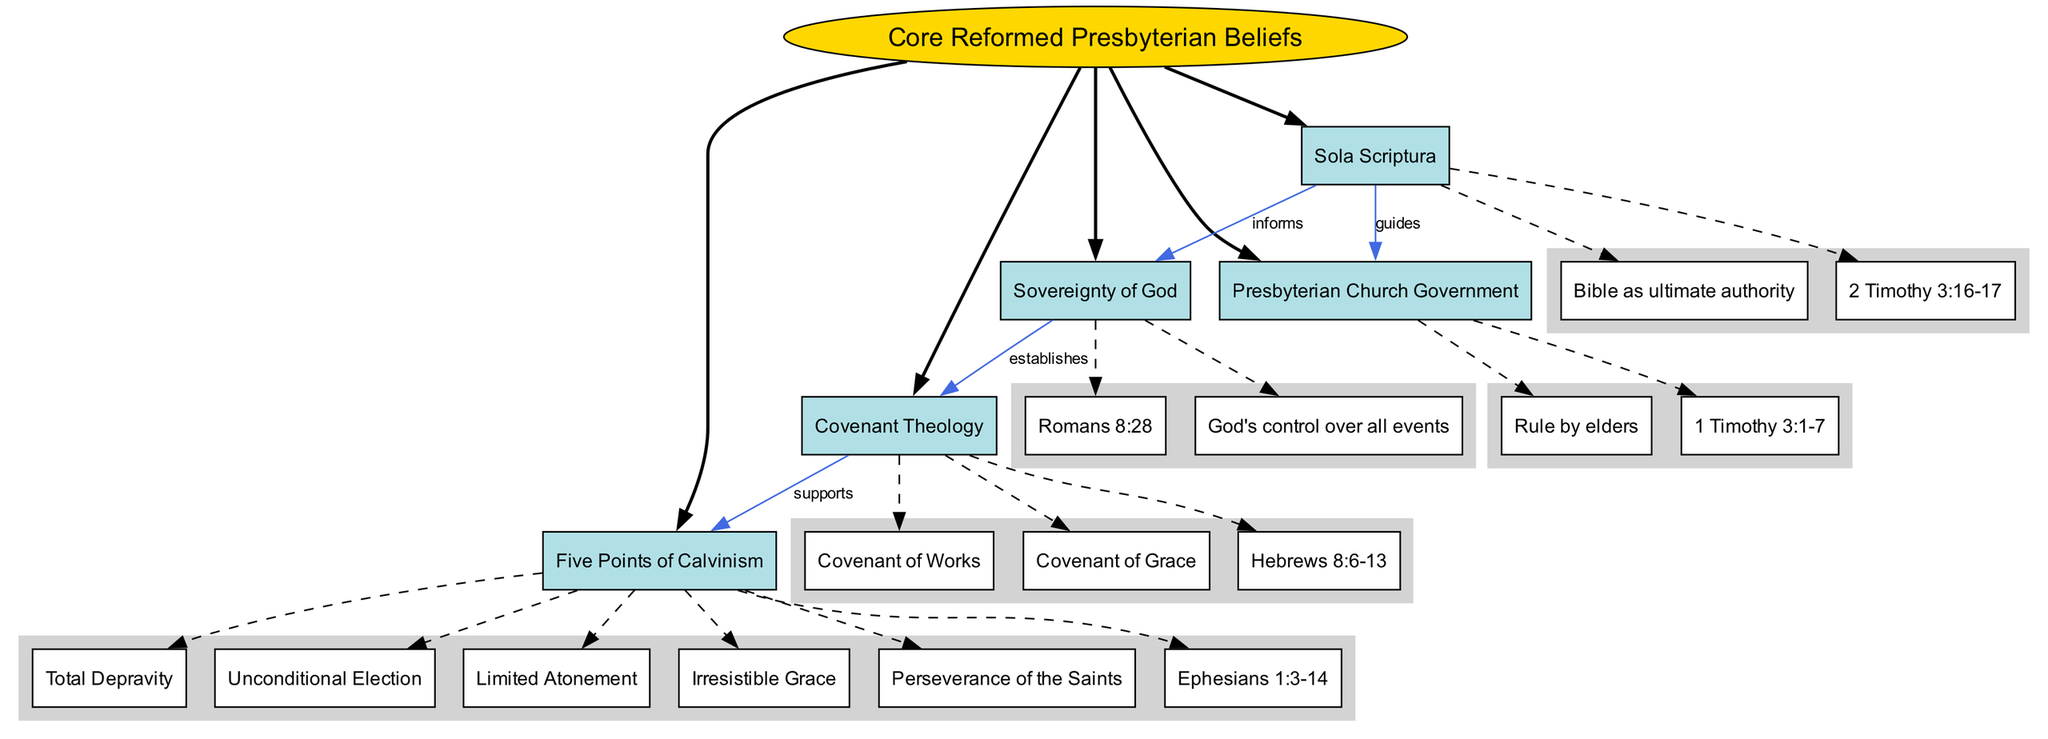What are the five core beliefs represented in the diagram? The diagram lists five main nodes that represent the core beliefs of Reformed Presbyterianism: Sola Scriptura, Sovereignty of God, Covenant Theology, Five Points of Calvinism, and Presbyterian Church Government.
Answer: Sola Scriptura, Sovereignty of God, Covenant Theology, Five Points of Calvinism, Presbyterian Church Government Which node details the Bible as the ultimate authority? The "Sola Scriptura" node is associated with the belief that the Bible is the ultimate authority. This is clearly shown in the sub-nodes connected to "Sola Scriptura".
Answer: Sola Scriptura How many sub-nodes are under Covenant Theology? The "Covenant Theology" node has three sub-nodes associated with it: Covenant of Works, Covenant of Grace, and the biblical reference of Hebrews 8:6-13, indicating there are three sub-nodes.
Answer: 3 What does the "Sovereignty of God" node inform? According to the diagram, "Sola Scriptura" informs "Sovereignty of God," as indicated by the connection labeled "informs."
Answer: Sola Scriptura Which biblical reference supports the Five Points of Calvinism? The "Five Points of Calvinism" node cites Ephesians 1:3-14 as its supporting biblical reference. This is directly stated in the sub-nodes for that main belief.
Answer: Ephesians 1:3-14 What establishes Covenant Theology according to the diagram? The diagram shows that "Sovereignty of God" establishes "Covenant Theology," as indicated by the connection labeled "establishes." This means that the belief in God's sovereignty lays the groundwork for understanding the covenants.
Answer: Sovereignty of God What type of church government is described in the diagram? The node representing church government specifies "Presbyterian Church Government," which indicates the form of governance followed in Reformed Presbyterianism, specifically the rule by elders as indicated in its sub-nodes.
Answer: Presbyterian Church Government Which connection in the diagram connects Sola Scriptura to church governance? The diagram indicates that "Sola Scriptura" guides "Presbyterian Church Government," demonstrated by the connection labeled "guides." This shows the foundational role of scripture in directing church governance.
Answer: guides 